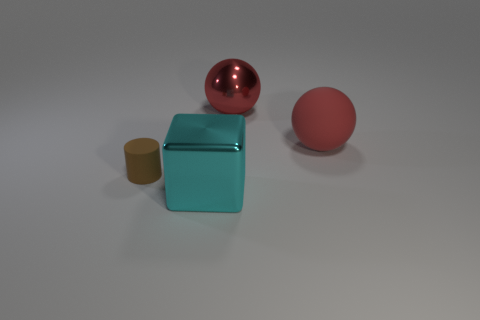Add 3 large shiny spheres. How many objects exist? 7 Add 4 big green matte blocks. How many big green matte blocks exist? 4 Subtract 1 brown cylinders. How many objects are left? 3 Subtract all blocks. How many objects are left? 3 Subtract 2 balls. How many balls are left? 0 Subtract all brown blocks. Subtract all red cylinders. How many blocks are left? 1 Subtract all shiny balls. Subtract all large red matte spheres. How many objects are left? 2 Add 3 big things. How many big things are left? 6 